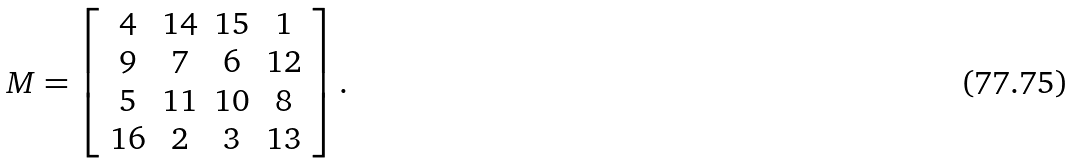<formula> <loc_0><loc_0><loc_500><loc_500>M = \left [ \begin{array} { c c c c } 4 & 1 4 & 1 5 & 1 \\ 9 & 7 & 6 & 1 2 \\ 5 & 1 1 & 1 0 & 8 \\ 1 6 & 2 & 3 & 1 3 \end{array} \right ] .</formula> 